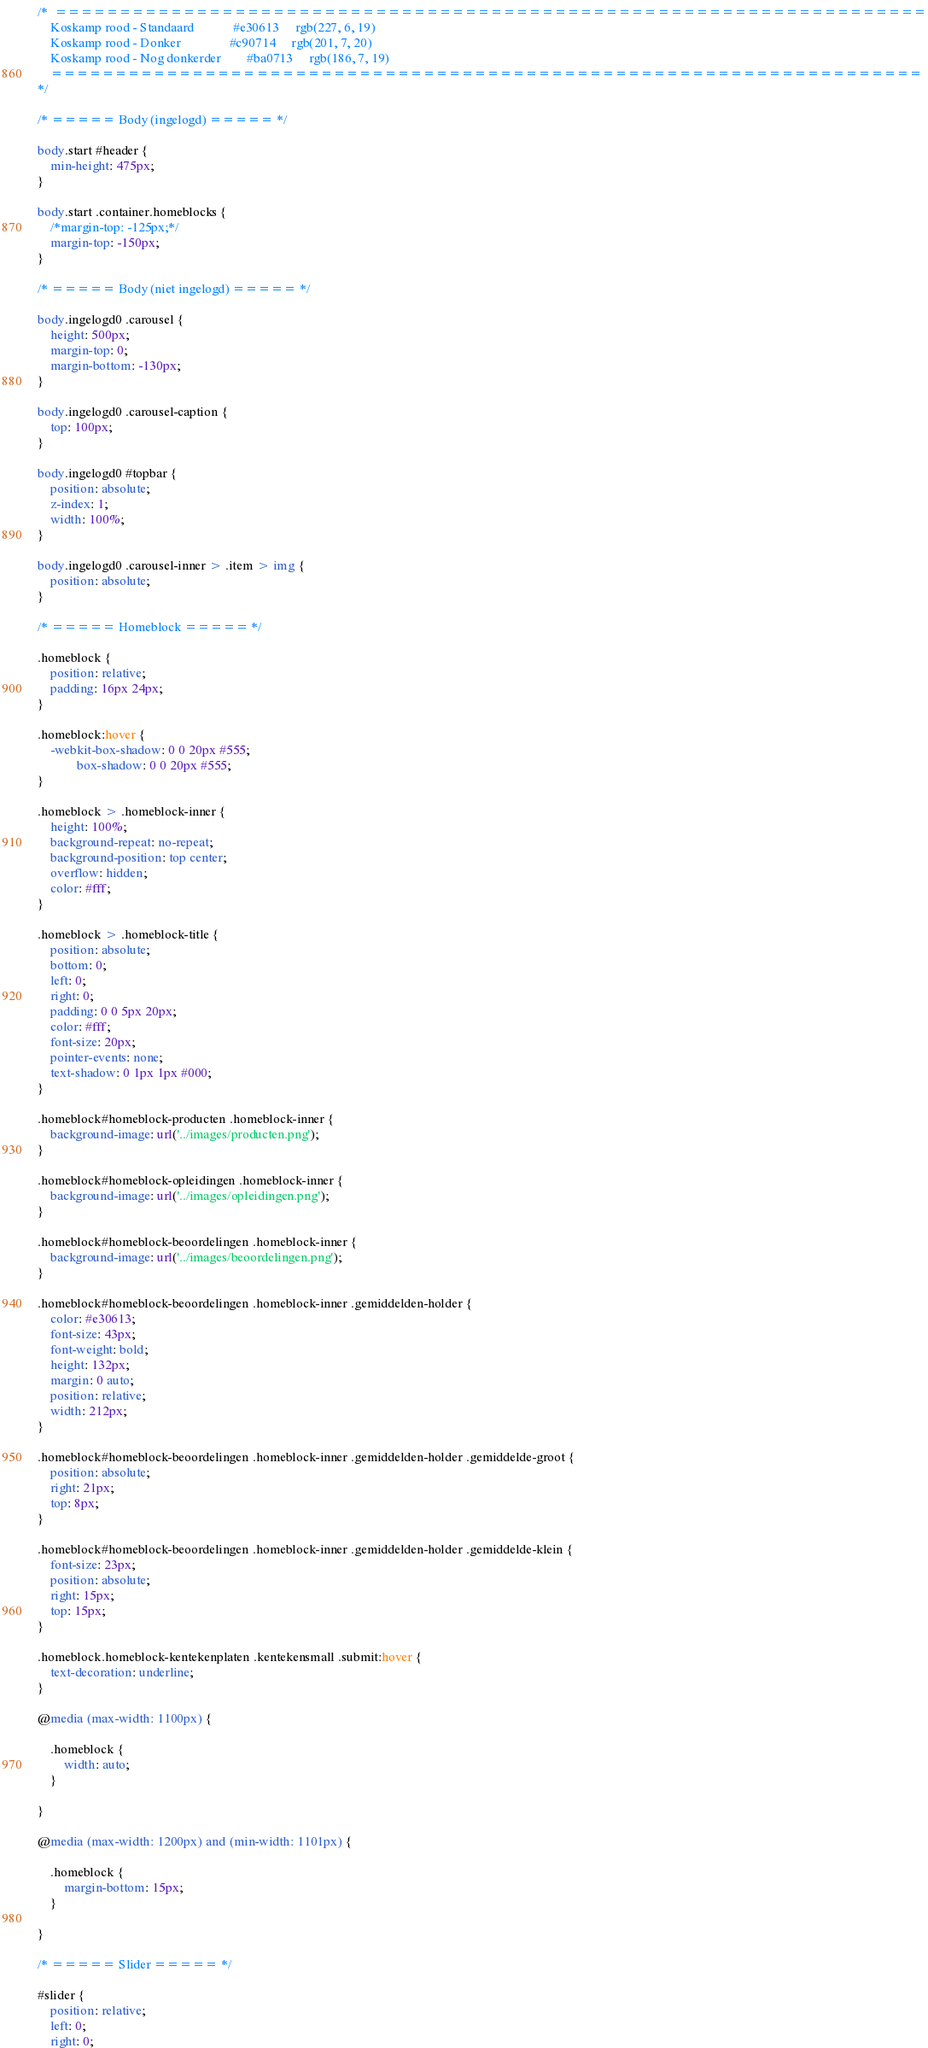<code> <loc_0><loc_0><loc_500><loc_500><_CSS_>/*  ====================================================================
    Koskamp rood - Standaard            #e30613     rgb(227, 6, 19)
    Koskamp rood - Donker               #c90714     rgb(201, 7, 20)
    Koskamp rood - Nog donkerder        #ba0713     rgb(186, 7, 19)
    ====================================================================
*/

/* ===== Body (ingelogd) ===== */

body.start #header {
    min-height: 475px;
}

body.start .container.homeblocks {
    /*margin-top: -125px;*/
    margin-top: -150px;
}

/* ===== Body (niet ingelogd) ===== */

body.ingelogd0 .carousel {
    height: 500px;
    margin-top: 0;
    margin-bottom: -130px;
}

body.ingelogd0 .carousel-caption {
    top: 100px;
}

body.ingelogd0 #topbar {
    position: absolute;
    z-index: 1;
    width: 100%;
}

body.ingelogd0 .carousel-inner > .item > img {
    position: absolute;
}

/* ===== Homeblock ===== */

.homeblock {
    position: relative;
    padding: 16px 24px;
}

.homeblock:hover {
    -webkit-box-shadow: 0 0 20px #555;
            box-shadow: 0 0 20px #555;
}

.homeblock > .homeblock-inner {
    height: 100%;
    background-repeat: no-repeat;
    background-position: top center;
    overflow: hidden;
    color: #fff;
}

.homeblock > .homeblock-title {
    position: absolute;
    bottom: 0;
    left: 0;
    right: 0;
    padding: 0 0 5px 20px;
    color: #fff;
    font-size: 20px;
    pointer-events: none;
    text-shadow: 0 1px 1px #000;
}

.homeblock#homeblock-producten .homeblock-inner {
    background-image: url('../images/producten.png');
}

.homeblock#homeblock-opleidingen .homeblock-inner {
    background-image: url('../images/opleidingen.png');
}

.homeblock#homeblock-beoordelingen .homeblock-inner {
    background-image: url('../images/beoordelingen.png');
}

.homeblock#homeblock-beoordelingen .homeblock-inner .gemiddelden-holder {
    color: #e30613;
    font-size: 43px;
    font-weight: bold;
    height: 132px;
    margin: 0 auto;
    position: relative;
    width: 212px;
}

.homeblock#homeblock-beoordelingen .homeblock-inner .gemiddelden-holder .gemiddelde-groot {
    position: absolute;
    right: 21px;
    top: 8px;
}

.homeblock#homeblock-beoordelingen .homeblock-inner .gemiddelden-holder .gemiddelde-klein {
    font-size: 23px;
    position: absolute;
    right: 15px;
    top: 15px;
}

.homeblock.homeblock-kentekenplaten .kentekensmall .submit:hover {
    text-decoration: underline;
}

@media (max-width: 1100px) {

    .homeblock {
        width: auto;
    }

}

@media (max-width: 1200px) and (min-width: 1101px) {

    .homeblock {
        margin-bottom: 15px;
    }

}

/* ===== Slider ===== */

#slider {
    position: relative;
    left: 0;
    right: 0;</code> 